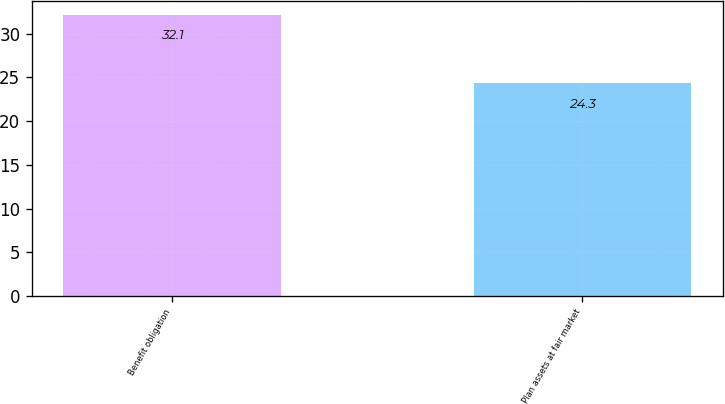<chart> <loc_0><loc_0><loc_500><loc_500><bar_chart><fcel>Benefit obligation<fcel>Plan assets at fair market<nl><fcel>32.1<fcel>24.3<nl></chart> 